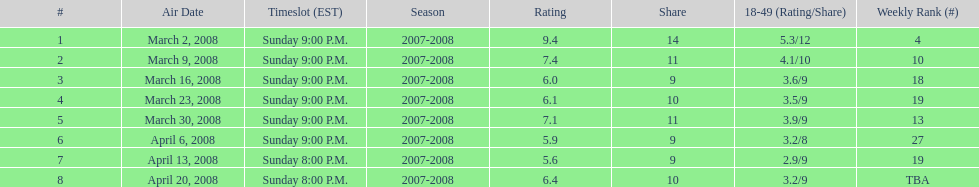What episode had the highest rating? March 2, 2008. 